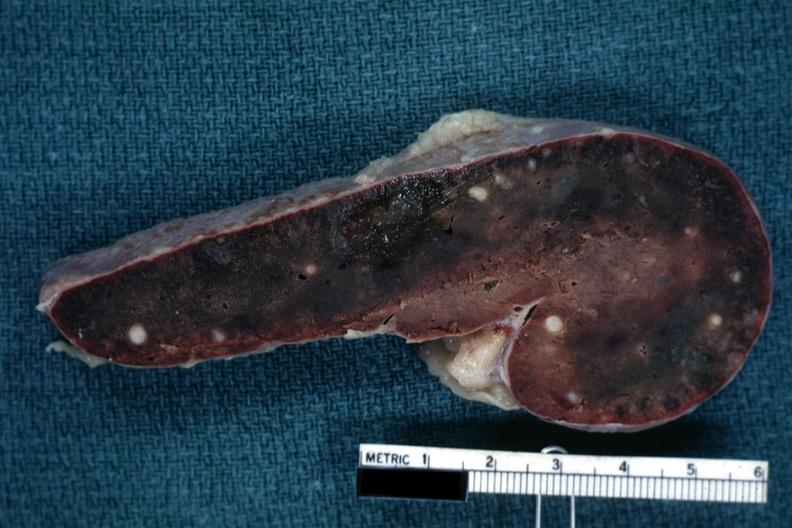what is fixed tissue cut?
Answer the question using a single word or phrase. Surface congested parenchyma with obvious granulomas 